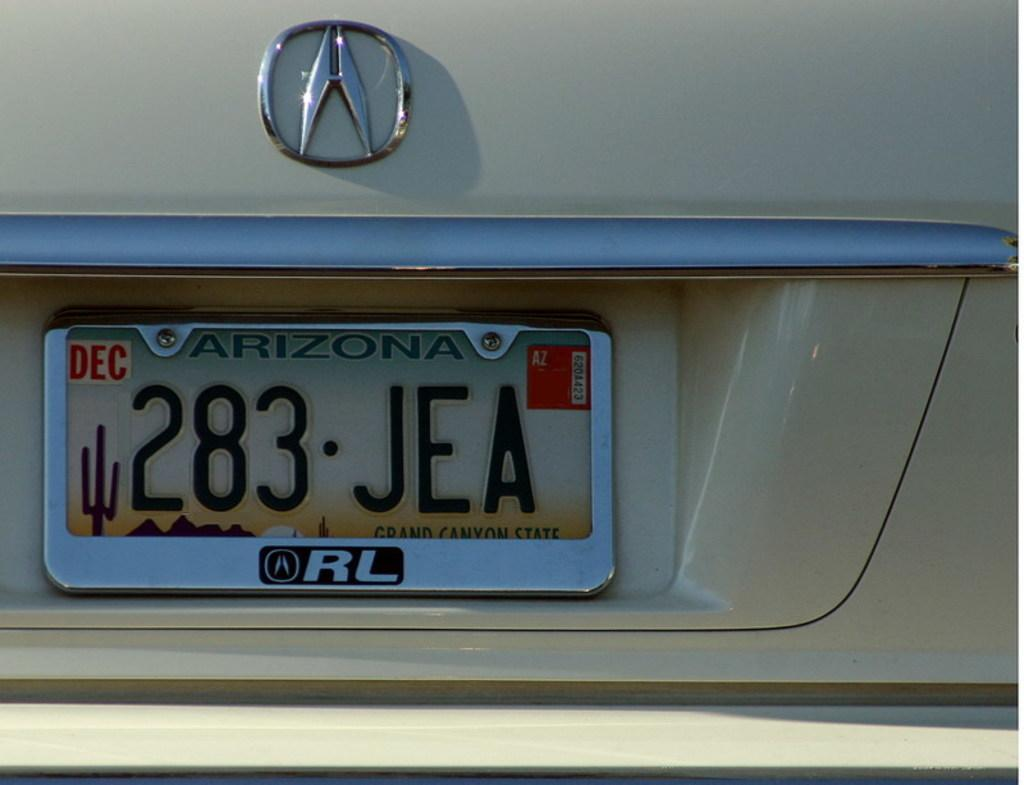<image>
Render a clear and concise summary of the photo. white vehicle with december arizona tags 283 JEA 